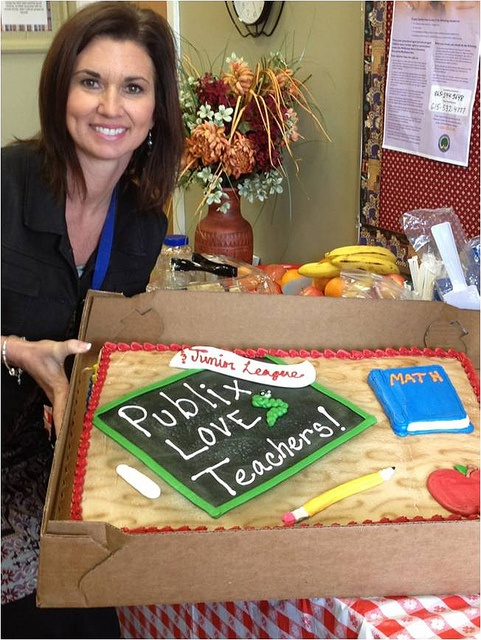Describe the objects in this image and their specific colors. I can see cake in white, tan, and gray tones, people in white, black, gray, and tan tones, potted plant in white, maroon, black, brown, and olive tones, vase in white, maroon, and brown tones, and banana in white, gold, olive, and orange tones in this image. 